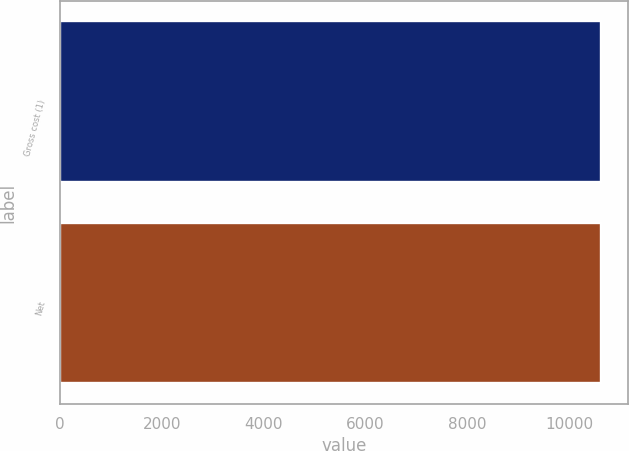Convert chart to OTSL. <chart><loc_0><loc_0><loc_500><loc_500><bar_chart><fcel>Gross cost (1)<fcel>Net<nl><fcel>10634<fcel>10634.1<nl></chart> 